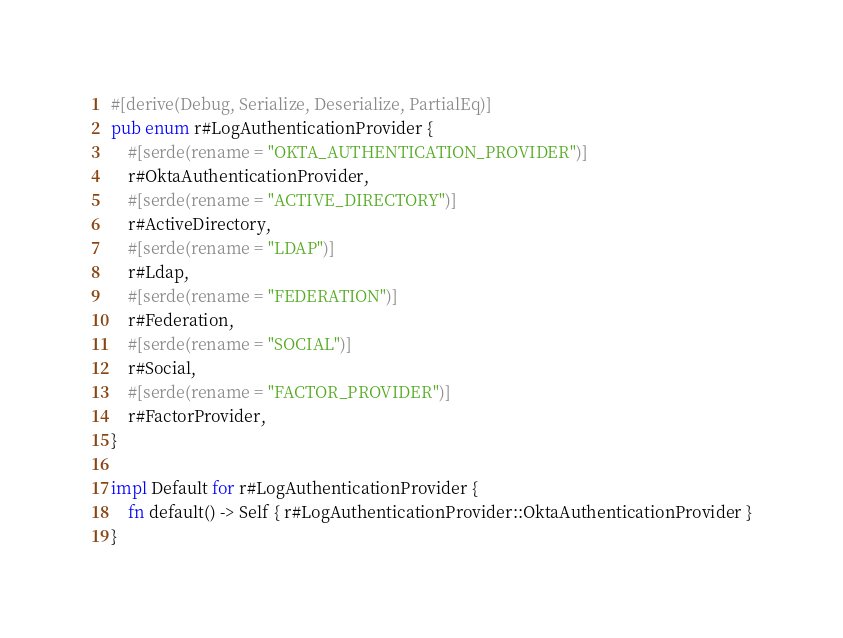Convert code to text. <code><loc_0><loc_0><loc_500><loc_500><_Rust_>#[derive(Debug, Serialize, Deserialize, PartialEq)]
pub enum r#LogAuthenticationProvider {
    #[serde(rename = "OKTA_AUTHENTICATION_PROVIDER")]
    r#OktaAuthenticationProvider,
    #[serde(rename = "ACTIVE_DIRECTORY")]
    r#ActiveDirectory,
    #[serde(rename = "LDAP")]
    r#Ldap,
    #[serde(rename = "FEDERATION")]
    r#Federation,
    #[serde(rename = "SOCIAL")]
    r#Social,
    #[serde(rename = "FACTOR_PROVIDER")]
    r#FactorProvider,
}

impl Default for r#LogAuthenticationProvider {
    fn default() -> Self { r#LogAuthenticationProvider::OktaAuthenticationProvider }
}
</code> 